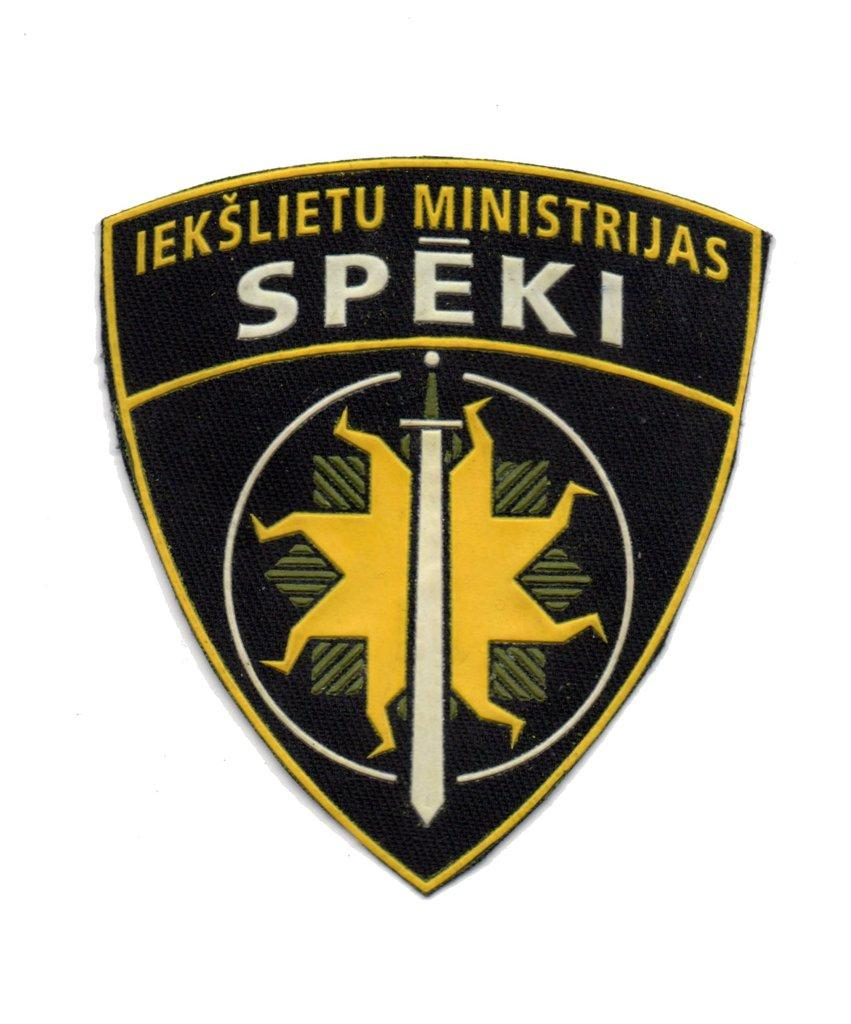What is present in the image that represents a brand or company? There is a logo in the image. Can you describe the logo in the image? The logo has writing on it. What is the logo doing in the image? Logos do not perform actions like humans or animals, so this question is not applicable to the image. 